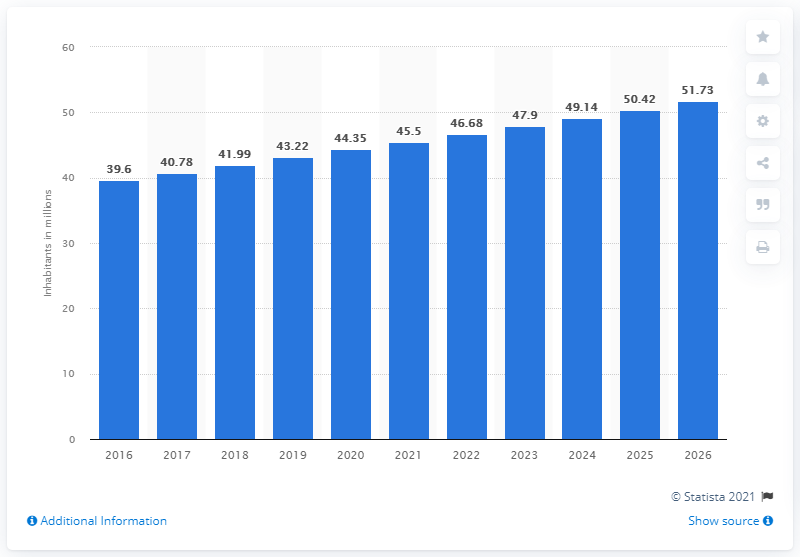Highlight a few significant elements in this photo. In 2020, the population of Sudan was 44.35 million. 